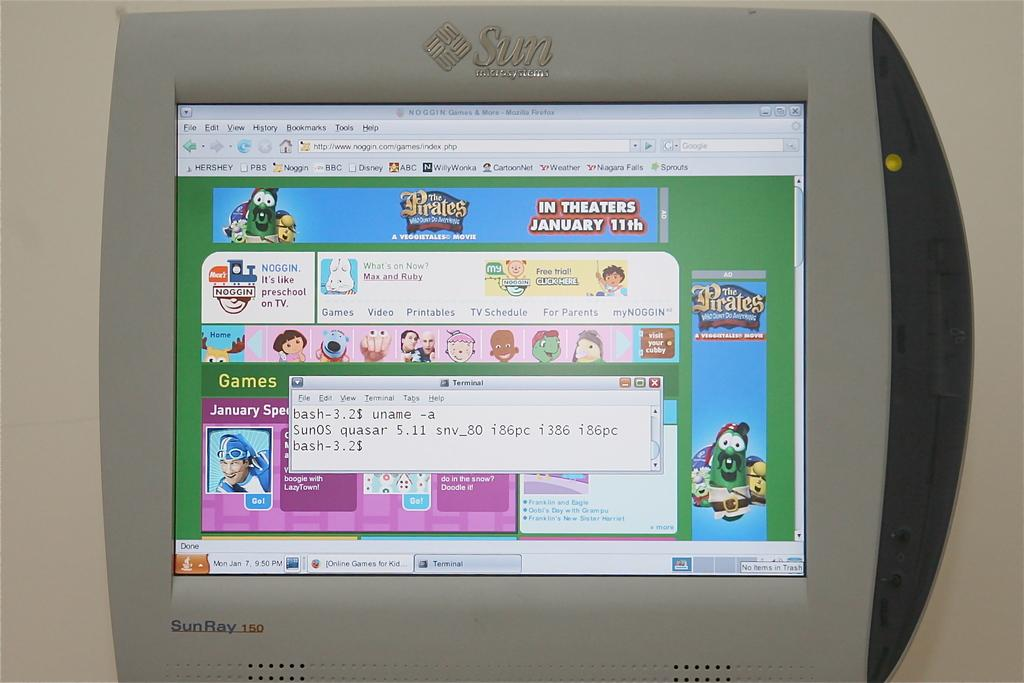<image>
Render a clear and concise summary of the photo. A small display screen shows The Pirates Who Don't Do Anything. 